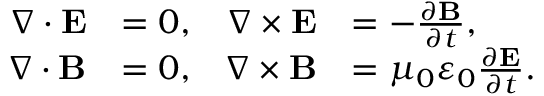<formula> <loc_0><loc_0><loc_500><loc_500>{ \begin{array} { r l r l } { \nabla \cdot E } & { = 0 , } & { \nabla \times E } & { = - { \frac { \partial B } { \partial t } } , } \\ { \nabla \cdot B } & { = 0 , } & { \nabla \times B } & { = \mu _ { 0 } \varepsilon _ { 0 } { \frac { \partial E } { \partial t } } . } \end{array} }</formula> 